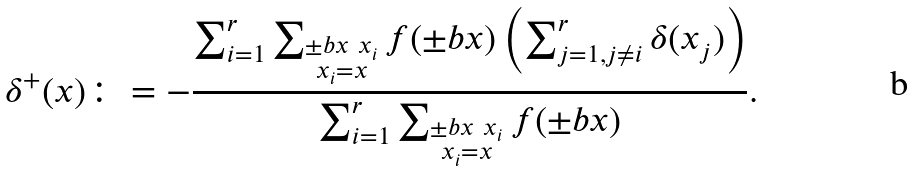<formula> <loc_0><loc_0><loc_500><loc_500>\delta ^ { + } ( x ) \colon = - \frac { \sum _ { i = 1 } ^ { r } \sum _ { \substack { \pm b { x } \ x _ { i } \\ x _ { i } = x } } f ( \pm b { x } ) \left ( \sum _ { j = 1 , j \ne i } ^ { r } \delta ( x _ { j } ) \right ) } { \sum _ { i = 1 } ^ { r } \sum _ { \substack { \pm b { x } \ x _ { i } \\ x _ { i } = x } } f ( \pm b { x } ) } .</formula> 